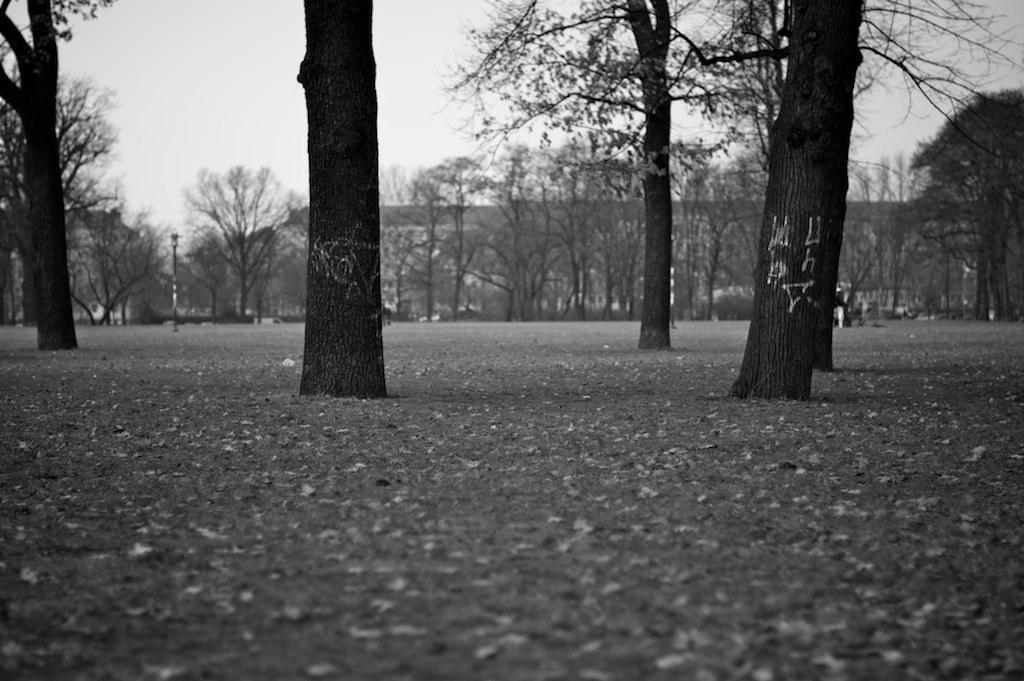What type of natural elements can be seen in the image? There are trees in the image. What type of artificial elements can be seen in the image? There are street lights in the image. What is present on the ground in the image? There are objects on the ground in the image. What is visible in the background of the image? The sky is visible in the background of the image. How is the image presented in terms of color? The image is black and white in color. How many toothbrushes are visible on the tray in the image? There is no tray or toothbrushes present in the image. What type of mice can be seen running around in the image? There are no mice present in the image. 